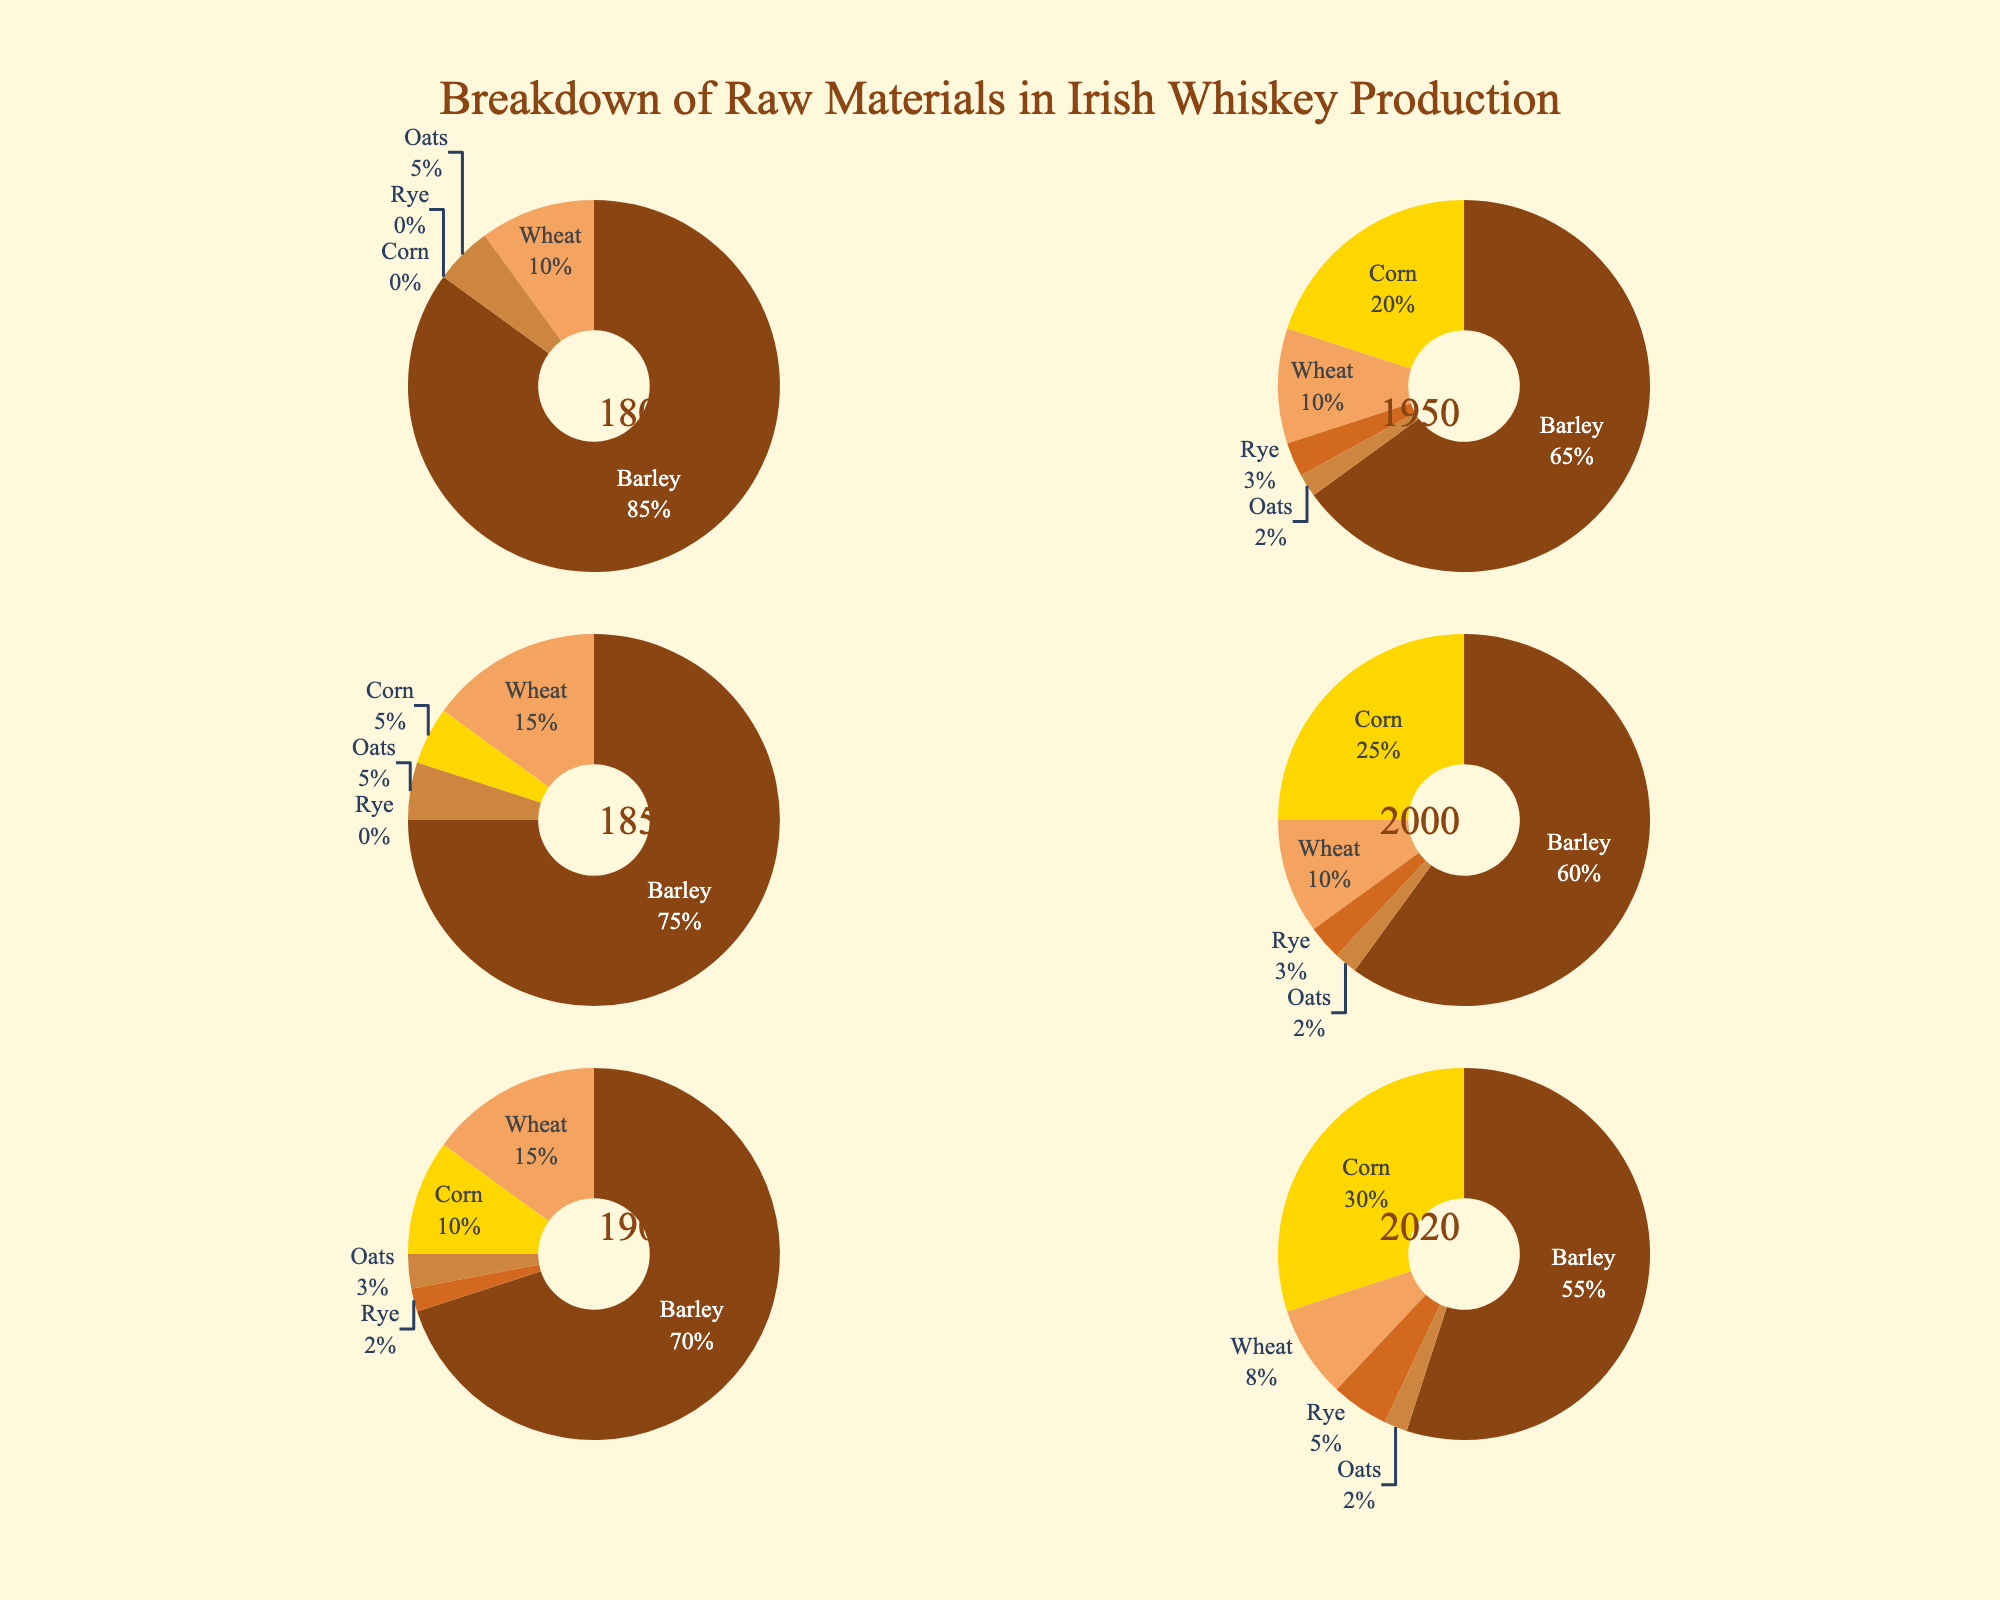What is the percentage of barley used in Irish whiskey production in 1800 compared to 2020? To answer this question, look at the labels for the years 1800 and 2020 in the pie charts. In 1800, barley usage is 85%, and in 2020, it is 55%.
Answer: 85% in 1800, 55% in 2020 How did the use of corn change from 1850 to 2020? Find the percentage of corn used in 1850, which is 5%, and compare it to the percentage in 2020, which is 30%.
Answer: Increased from 5% to 30% Which raw material had the most significant percentage increase from 1800 to 2020? Compare the percentage changes for each material from 1800 to 2020. Barley decreased, corn increased from 0% to 30%, wheat decreased, rye increased from 0% to 5%, and oats slightly decreased. The most significant increase is corn.
Answer: Corn By how many percentage points did the use of barley decrease from 1800 to 2020? Subtract the percentage of barley used in 2020 from that in 1800: 85% (1800) - 55% (2020) = 30 percentage points.
Answer: 30 percentage points In which year was the use of wheat at its peak, and what was the percentage? Review each pie chart to find the year with the highest percentage of wheat. The peak is in 1900 and 1850, both with 15%.
Answer: 1850 and 1900, 15% How does the percentage of rye used in 2020 compare to that in 1900? The percentage of rye in 2020 is 5%, and in 1900, it is 2%. So, rye usage increased by 3 percentage points from 1900 to 2020.
Answer: Increased by 3 percentage points What is the total percentage of barley, corn, and oats used in 2000? Add the percentages of barley, corn, and oats for the year 2000: 60% (barley) + 25% (corn) + 2% (oats) = 87%.
Answer: 87% Which raw material remained most stable in percentage from 1800 to 2020? Compare the changes in percentages for each raw material over the years. Oats remain relatively stable, changing from 5% in 1800 to 2% in 2020.
Answer: Oats How did the use of raw materials diversify from 1800 to 2020? In 1800, barley dominated with 85%, and now, by 2020, the percentages are more spread out among multiple materials with the highest being 55% for barley, 30% for corn, and smaller amounts of rye, wheat, and oats indicating diversification.
Answer: Diversified 